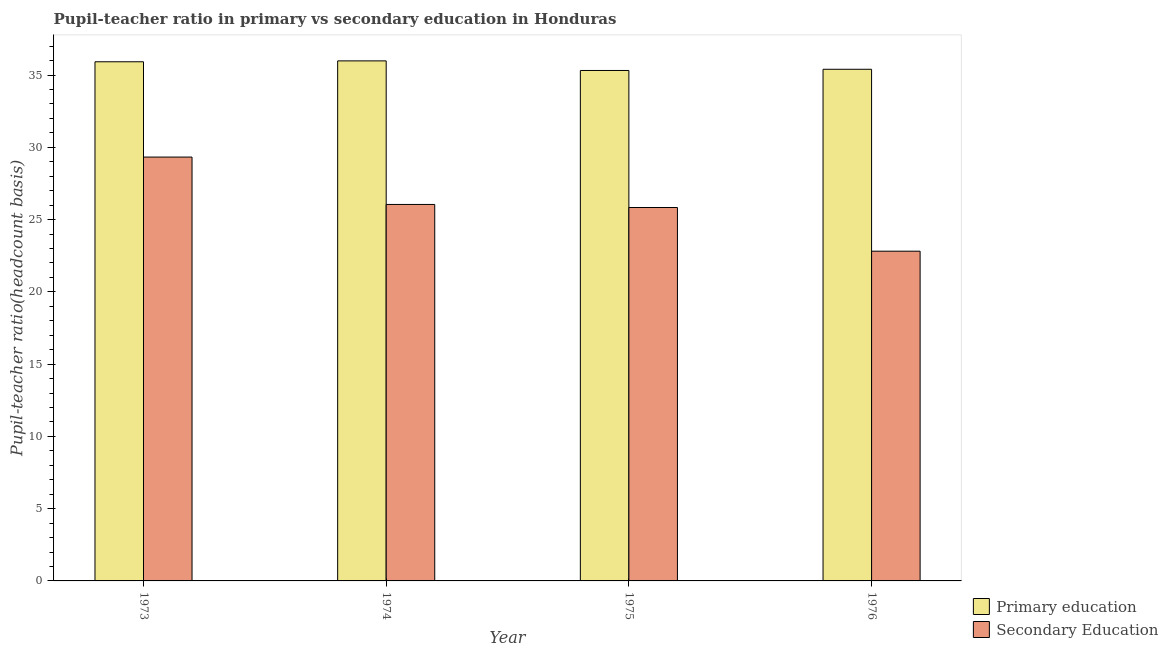How many different coloured bars are there?
Make the answer very short. 2. How many groups of bars are there?
Offer a very short reply. 4. Are the number of bars per tick equal to the number of legend labels?
Your answer should be compact. Yes. How many bars are there on the 4th tick from the left?
Give a very brief answer. 2. What is the label of the 4th group of bars from the left?
Provide a succinct answer. 1976. In how many cases, is the number of bars for a given year not equal to the number of legend labels?
Offer a very short reply. 0. What is the pupil-teacher ratio in primary education in 1974?
Offer a very short reply. 35.98. Across all years, what is the maximum pupil-teacher ratio in primary education?
Provide a succinct answer. 35.98. Across all years, what is the minimum pupil teacher ratio on secondary education?
Ensure brevity in your answer.  22.81. In which year was the pupil-teacher ratio in primary education minimum?
Your response must be concise. 1975. What is the total pupil teacher ratio on secondary education in the graph?
Your answer should be compact. 104.03. What is the difference between the pupil teacher ratio on secondary education in 1973 and that in 1975?
Your answer should be very brief. 3.49. What is the difference between the pupil teacher ratio on secondary education in 1973 and the pupil-teacher ratio in primary education in 1976?
Provide a succinct answer. 6.51. What is the average pupil teacher ratio on secondary education per year?
Your response must be concise. 26.01. In the year 1973, what is the difference between the pupil teacher ratio on secondary education and pupil-teacher ratio in primary education?
Make the answer very short. 0. What is the ratio of the pupil teacher ratio on secondary education in 1973 to that in 1976?
Offer a very short reply. 1.29. Is the difference between the pupil teacher ratio on secondary education in 1973 and 1975 greater than the difference between the pupil-teacher ratio in primary education in 1973 and 1975?
Provide a succinct answer. No. What is the difference between the highest and the second highest pupil teacher ratio on secondary education?
Give a very brief answer. 3.28. What is the difference between the highest and the lowest pupil-teacher ratio in primary education?
Your response must be concise. 0.66. In how many years, is the pupil teacher ratio on secondary education greater than the average pupil teacher ratio on secondary education taken over all years?
Give a very brief answer. 2. Is the sum of the pupil-teacher ratio in primary education in 1975 and 1976 greater than the maximum pupil teacher ratio on secondary education across all years?
Give a very brief answer. Yes. What does the 1st bar from the left in 1974 represents?
Your response must be concise. Primary education. What does the 1st bar from the right in 1976 represents?
Your response must be concise. Secondary Education. How many years are there in the graph?
Offer a terse response. 4. What is the difference between two consecutive major ticks on the Y-axis?
Your response must be concise. 5. Are the values on the major ticks of Y-axis written in scientific E-notation?
Make the answer very short. No. Does the graph contain any zero values?
Your answer should be very brief. No. Where does the legend appear in the graph?
Give a very brief answer. Bottom right. How many legend labels are there?
Your answer should be very brief. 2. What is the title of the graph?
Your response must be concise. Pupil-teacher ratio in primary vs secondary education in Honduras. What is the label or title of the X-axis?
Offer a terse response. Year. What is the label or title of the Y-axis?
Provide a short and direct response. Pupil-teacher ratio(headcount basis). What is the Pupil-teacher ratio(headcount basis) of Primary education in 1973?
Your response must be concise. 35.92. What is the Pupil-teacher ratio(headcount basis) in Secondary Education in 1973?
Keep it short and to the point. 29.33. What is the Pupil-teacher ratio(headcount basis) in Primary education in 1974?
Offer a very short reply. 35.98. What is the Pupil-teacher ratio(headcount basis) of Secondary Education in 1974?
Provide a succinct answer. 26.05. What is the Pupil-teacher ratio(headcount basis) in Primary education in 1975?
Offer a terse response. 35.32. What is the Pupil-teacher ratio(headcount basis) in Secondary Education in 1975?
Give a very brief answer. 25.84. What is the Pupil-teacher ratio(headcount basis) in Primary education in 1976?
Provide a short and direct response. 35.4. What is the Pupil-teacher ratio(headcount basis) of Secondary Education in 1976?
Give a very brief answer. 22.81. Across all years, what is the maximum Pupil-teacher ratio(headcount basis) of Primary education?
Your response must be concise. 35.98. Across all years, what is the maximum Pupil-teacher ratio(headcount basis) of Secondary Education?
Offer a terse response. 29.33. Across all years, what is the minimum Pupil-teacher ratio(headcount basis) in Primary education?
Give a very brief answer. 35.32. Across all years, what is the minimum Pupil-teacher ratio(headcount basis) of Secondary Education?
Ensure brevity in your answer.  22.81. What is the total Pupil-teacher ratio(headcount basis) of Primary education in the graph?
Keep it short and to the point. 142.63. What is the total Pupil-teacher ratio(headcount basis) in Secondary Education in the graph?
Offer a very short reply. 104.03. What is the difference between the Pupil-teacher ratio(headcount basis) in Primary education in 1973 and that in 1974?
Provide a short and direct response. -0.06. What is the difference between the Pupil-teacher ratio(headcount basis) in Secondary Education in 1973 and that in 1974?
Ensure brevity in your answer.  3.28. What is the difference between the Pupil-teacher ratio(headcount basis) of Primary education in 1973 and that in 1975?
Provide a succinct answer. 0.6. What is the difference between the Pupil-teacher ratio(headcount basis) of Secondary Education in 1973 and that in 1975?
Your response must be concise. 3.49. What is the difference between the Pupil-teacher ratio(headcount basis) of Primary education in 1973 and that in 1976?
Give a very brief answer. 0.52. What is the difference between the Pupil-teacher ratio(headcount basis) in Secondary Education in 1973 and that in 1976?
Ensure brevity in your answer.  6.51. What is the difference between the Pupil-teacher ratio(headcount basis) in Primary education in 1974 and that in 1975?
Give a very brief answer. 0.66. What is the difference between the Pupil-teacher ratio(headcount basis) in Secondary Education in 1974 and that in 1975?
Give a very brief answer. 0.21. What is the difference between the Pupil-teacher ratio(headcount basis) of Primary education in 1974 and that in 1976?
Ensure brevity in your answer.  0.58. What is the difference between the Pupil-teacher ratio(headcount basis) in Secondary Education in 1974 and that in 1976?
Your answer should be compact. 3.24. What is the difference between the Pupil-teacher ratio(headcount basis) of Primary education in 1975 and that in 1976?
Offer a very short reply. -0.08. What is the difference between the Pupil-teacher ratio(headcount basis) in Secondary Education in 1975 and that in 1976?
Ensure brevity in your answer.  3.02. What is the difference between the Pupil-teacher ratio(headcount basis) of Primary education in 1973 and the Pupil-teacher ratio(headcount basis) of Secondary Education in 1974?
Offer a very short reply. 9.87. What is the difference between the Pupil-teacher ratio(headcount basis) of Primary education in 1973 and the Pupil-teacher ratio(headcount basis) of Secondary Education in 1975?
Keep it short and to the point. 10.08. What is the difference between the Pupil-teacher ratio(headcount basis) in Primary education in 1973 and the Pupil-teacher ratio(headcount basis) in Secondary Education in 1976?
Ensure brevity in your answer.  13.11. What is the difference between the Pupil-teacher ratio(headcount basis) of Primary education in 1974 and the Pupil-teacher ratio(headcount basis) of Secondary Education in 1975?
Offer a very short reply. 10.15. What is the difference between the Pupil-teacher ratio(headcount basis) of Primary education in 1974 and the Pupil-teacher ratio(headcount basis) of Secondary Education in 1976?
Provide a short and direct response. 13.17. What is the difference between the Pupil-teacher ratio(headcount basis) of Primary education in 1975 and the Pupil-teacher ratio(headcount basis) of Secondary Education in 1976?
Ensure brevity in your answer.  12.51. What is the average Pupil-teacher ratio(headcount basis) in Primary education per year?
Give a very brief answer. 35.66. What is the average Pupil-teacher ratio(headcount basis) in Secondary Education per year?
Your answer should be compact. 26.01. In the year 1973, what is the difference between the Pupil-teacher ratio(headcount basis) in Primary education and Pupil-teacher ratio(headcount basis) in Secondary Education?
Keep it short and to the point. 6.59. In the year 1974, what is the difference between the Pupil-teacher ratio(headcount basis) in Primary education and Pupil-teacher ratio(headcount basis) in Secondary Education?
Provide a succinct answer. 9.93. In the year 1975, what is the difference between the Pupil-teacher ratio(headcount basis) in Primary education and Pupil-teacher ratio(headcount basis) in Secondary Education?
Give a very brief answer. 9.48. In the year 1976, what is the difference between the Pupil-teacher ratio(headcount basis) in Primary education and Pupil-teacher ratio(headcount basis) in Secondary Education?
Your answer should be compact. 12.59. What is the ratio of the Pupil-teacher ratio(headcount basis) of Primary education in 1973 to that in 1974?
Give a very brief answer. 1. What is the ratio of the Pupil-teacher ratio(headcount basis) in Secondary Education in 1973 to that in 1974?
Provide a succinct answer. 1.13. What is the ratio of the Pupil-teacher ratio(headcount basis) in Secondary Education in 1973 to that in 1975?
Offer a terse response. 1.14. What is the ratio of the Pupil-teacher ratio(headcount basis) in Primary education in 1973 to that in 1976?
Offer a very short reply. 1.01. What is the ratio of the Pupil-teacher ratio(headcount basis) in Secondary Education in 1973 to that in 1976?
Your response must be concise. 1.29. What is the ratio of the Pupil-teacher ratio(headcount basis) of Primary education in 1974 to that in 1975?
Your answer should be compact. 1.02. What is the ratio of the Pupil-teacher ratio(headcount basis) in Secondary Education in 1974 to that in 1975?
Keep it short and to the point. 1.01. What is the ratio of the Pupil-teacher ratio(headcount basis) of Primary education in 1974 to that in 1976?
Keep it short and to the point. 1.02. What is the ratio of the Pupil-teacher ratio(headcount basis) in Secondary Education in 1974 to that in 1976?
Provide a succinct answer. 1.14. What is the ratio of the Pupil-teacher ratio(headcount basis) in Secondary Education in 1975 to that in 1976?
Keep it short and to the point. 1.13. What is the difference between the highest and the second highest Pupil-teacher ratio(headcount basis) in Primary education?
Give a very brief answer. 0.06. What is the difference between the highest and the second highest Pupil-teacher ratio(headcount basis) of Secondary Education?
Your response must be concise. 3.28. What is the difference between the highest and the lowest Pupil-teacher ratio(headcount basis) in Primary education?
Offer a terse response. 0.66. What is the difference between the highest and the lowest Pupil-teacher ratio(headcount basis) in Secondary Education?
Make the answer very short. 6.51. 